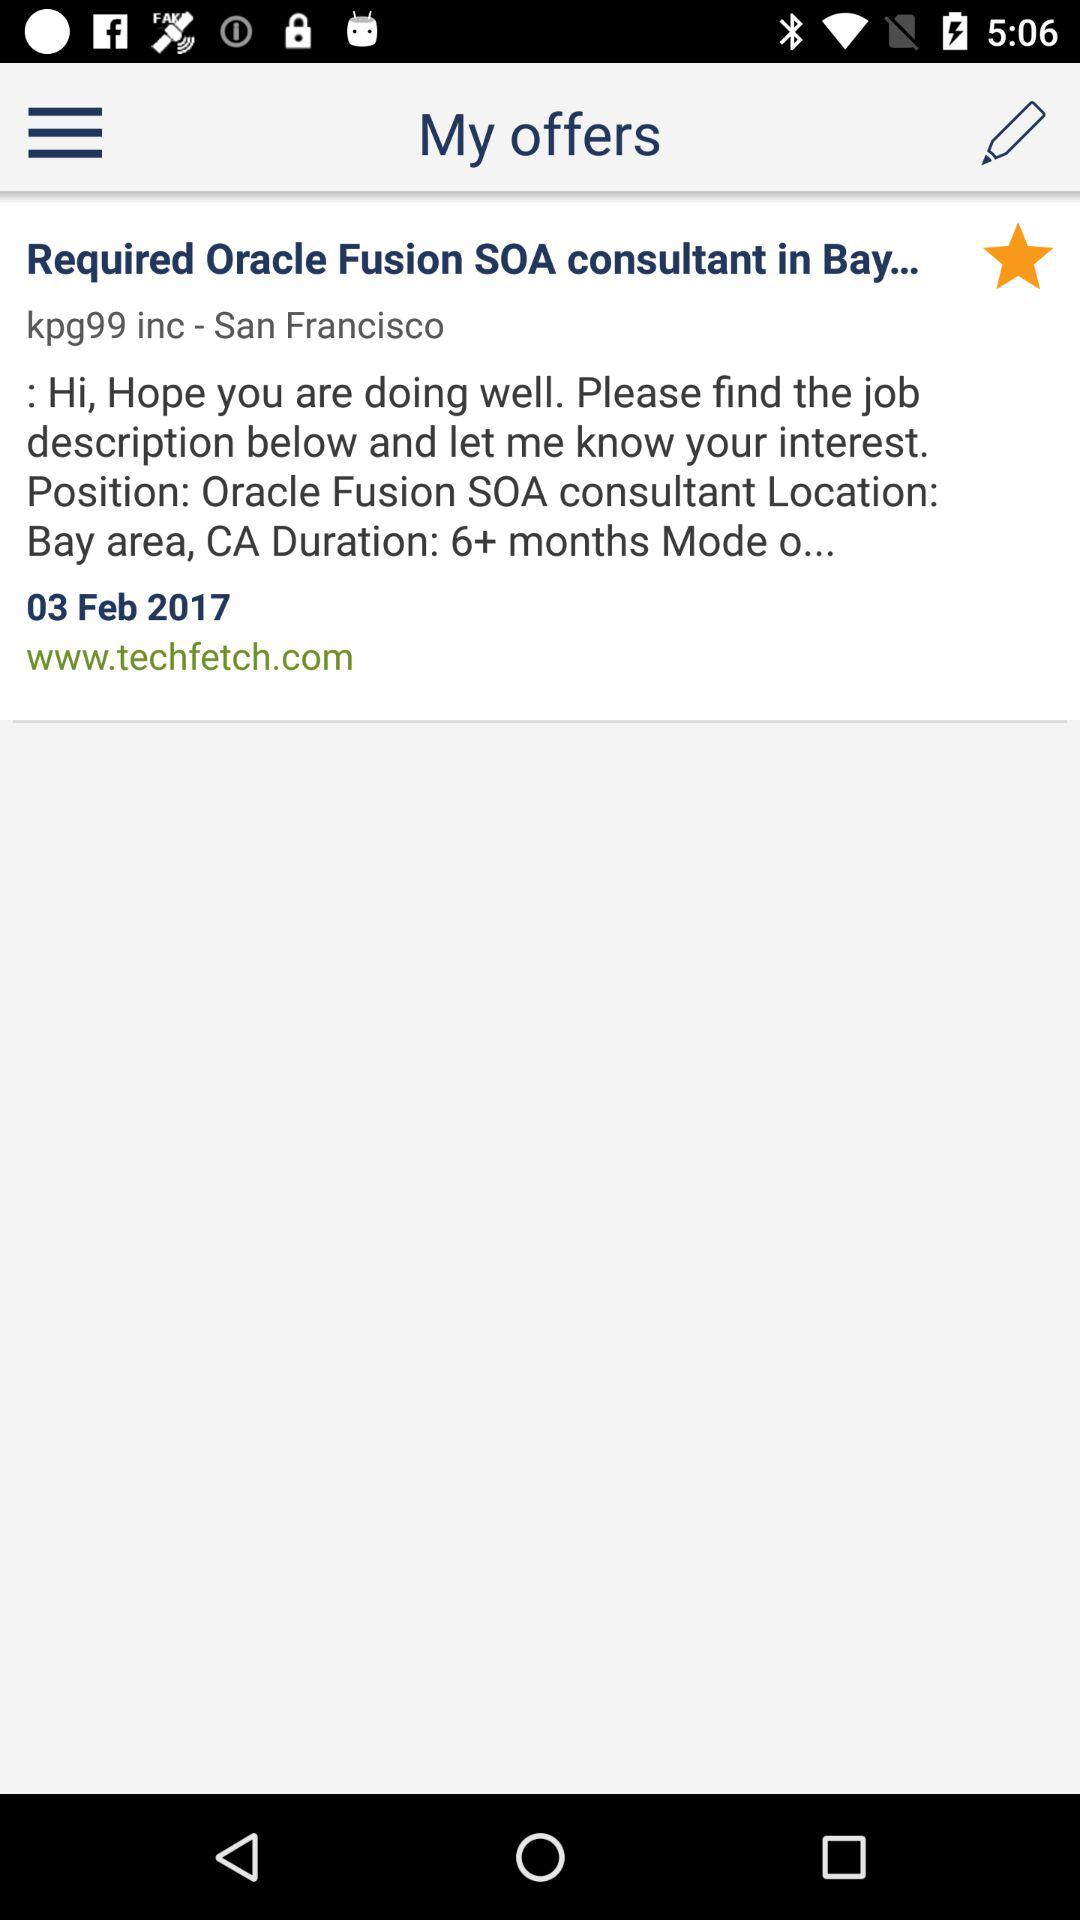What's the city name? The city name is "San Francisco". 